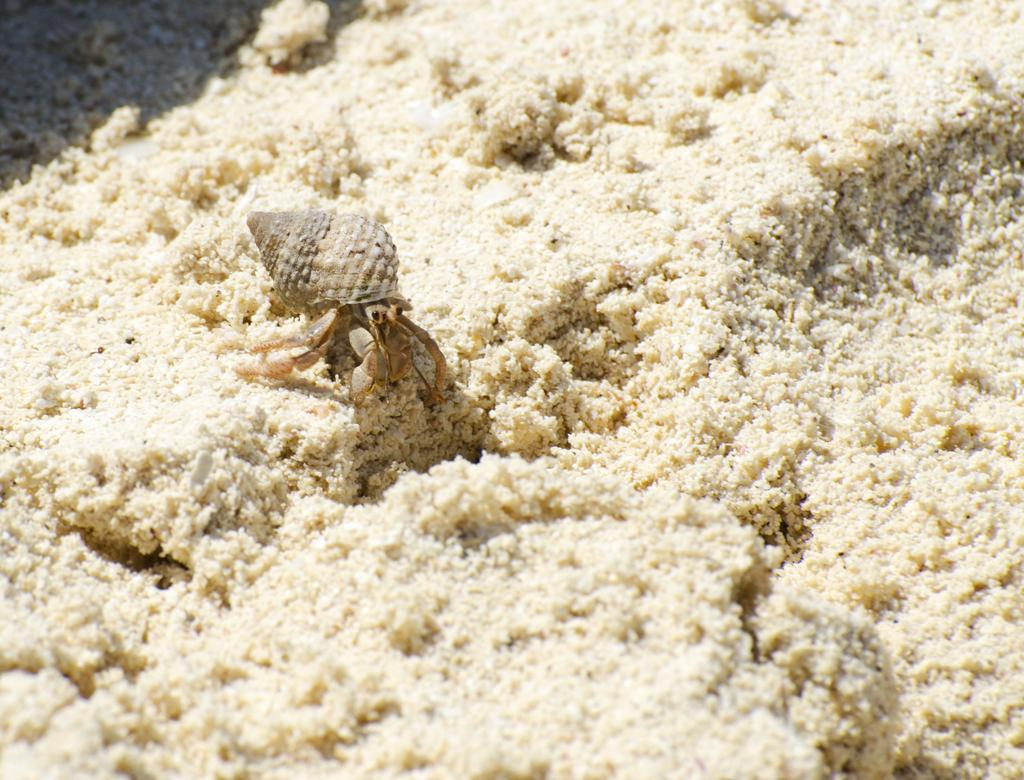What type of animal is in the image? There is a hermit crab in the image. Where is the hermit crab located? The hermit crab is on the ground. What type of linen is draped over the hermit crab in the image? There is no linen present in the image; it features a hermit crab on the ground. How many icicles can be seen hanging from the hermit crab in the image? There are no icicles present in the image; it features a hermit crab on the ground. 